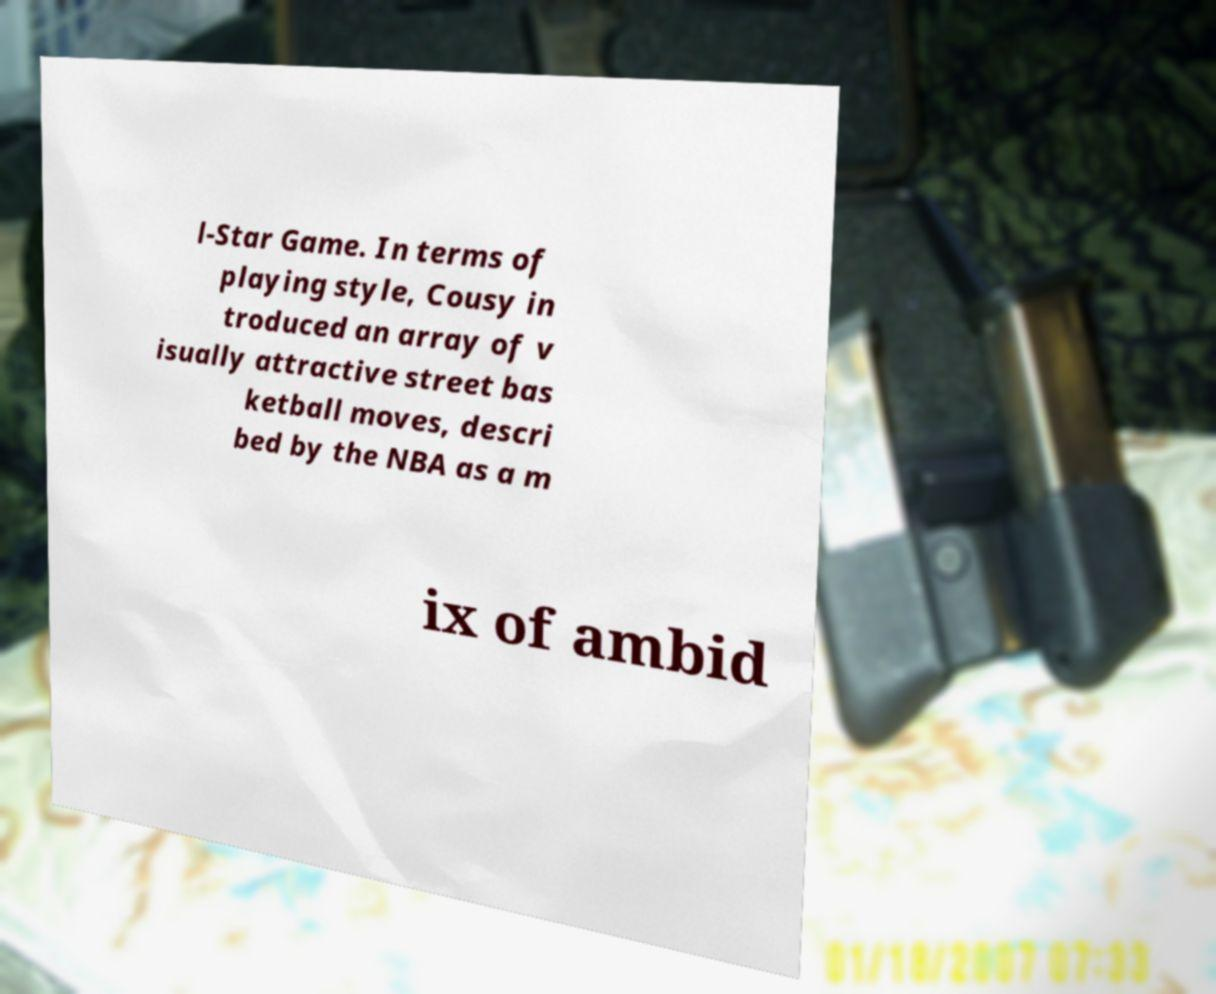Could you extract and type out the text from this image? l-Star Game. In terms of playing style, Cousy in troduced an array of v isually attractive street bas ketball moves, descri bed by the NBA as a m ix of ambid 